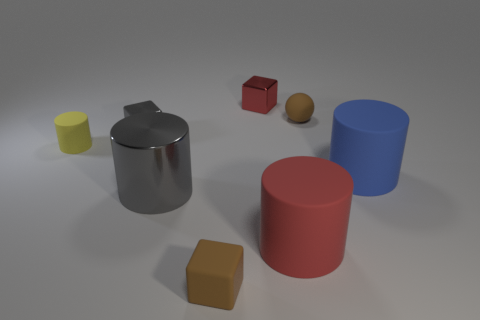Add 2 small red metal objects. How many objects exist? 10 Subtract all balls. How many objects are left? 7 Subtract 0 blue spheres. How many objects are left? 8 Subtract all blue shiny things. Subtract all tiny yellow matte things. How many objects are left? 7 Add 2 balls. How many balls are left? 3 Add 6 big blue matte cubes. How many big blue matte cubes exist? 6 